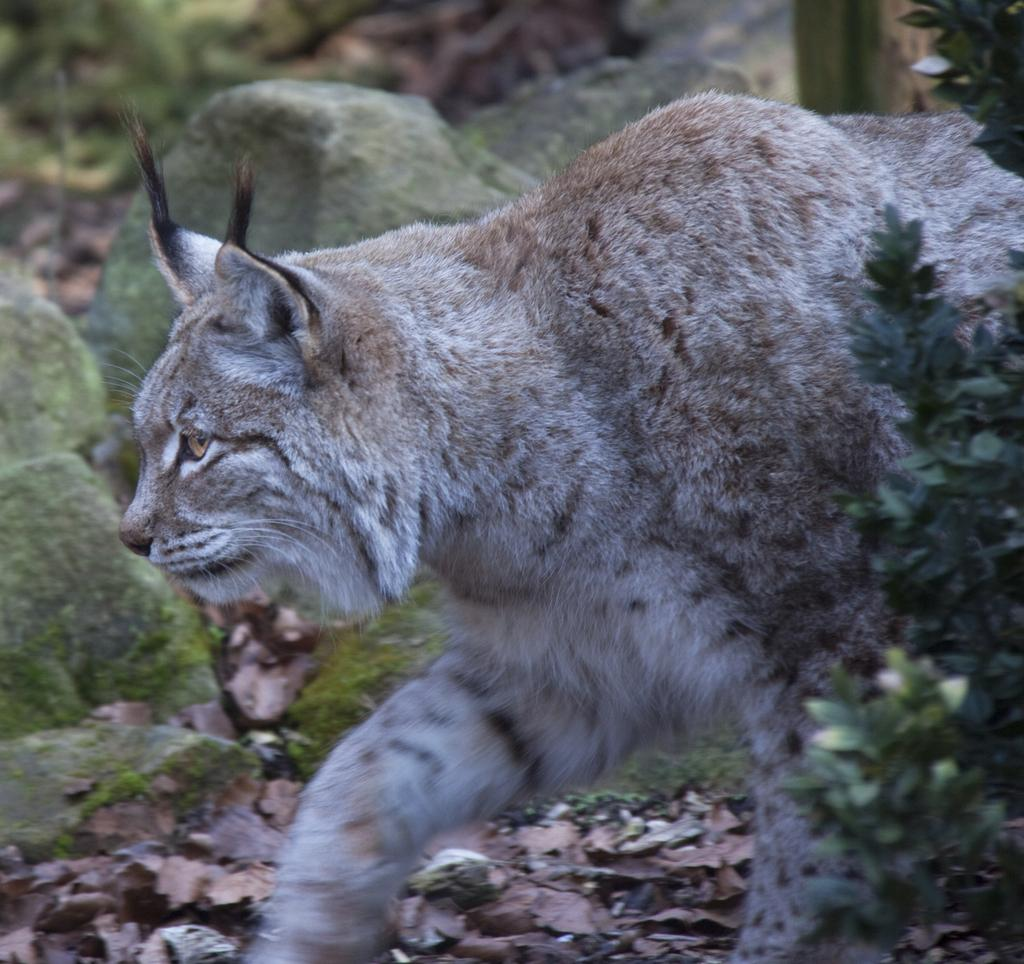What type of living organism is present in the image? There is an animal in the image. What type of vegetation is present in the image? There is a plant in the image. What type of inanimate object is present in the image? There is a stone in the image. Can you tell me how many people are in the group in the image? There is no group of people present in the image. What type of boat can be seen in the image? There is no boat present in the image. 